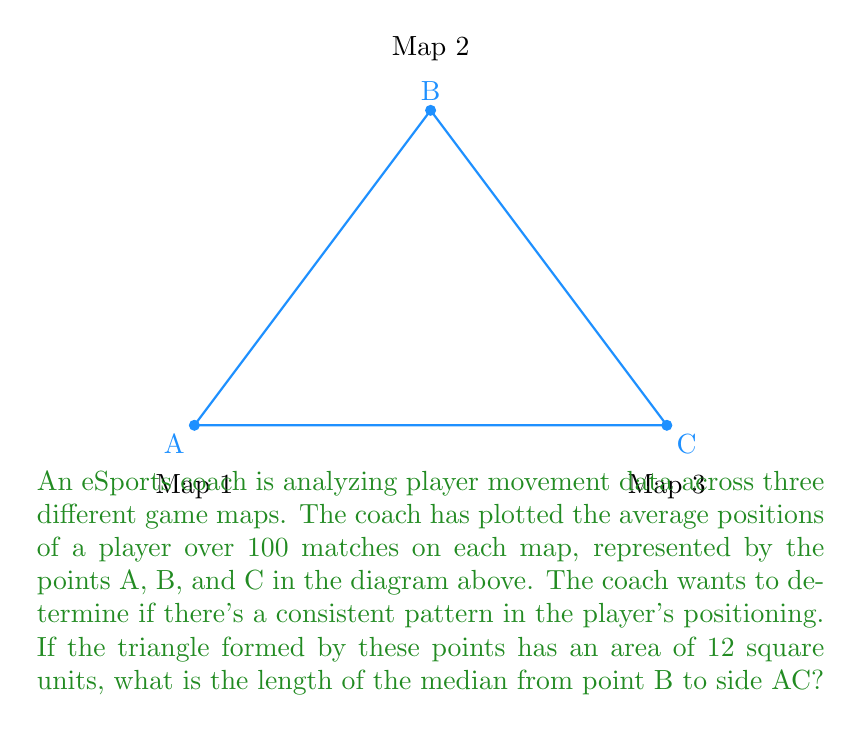Provide a solution to this math problem. Let's approach this step-by-step:

1) First, we need to recall the formula for the area of a triangle given the coordinates of its vertices. If we consider A as the origin (0,0), B as (3,4), and C as (6,0), we can use the formula:

   $$Area = \frac{1}{2}|x_1(y_2 - y_3) + x_2(y_3 - y_1) + x_3(y_1 - y_2)|$$

2) We're given that the area is 12 square units, so we don't need to calculate it. This information will be useful later.

3) To find the length of the median from B to AC, we can use the median formula:

   $$m_b^2 = \frac{1}{4}(2a^2 + 2c^2 - b^2)$$

   where $m_b$ is the median from B to AC, and a, b, c are the side lengths of the triangle.

4) We need to find the side lengths:
   AB = $\sqrt{3^2 + 4^2} = 5$
   BC = $\sqrt{3^2 + 4^2} = 5$
   AC = 6

5) Now we can plug these into the median formula:

   $$m_b^2 = \frac{1}{4}(2(6^2) + 2(5^2) - 5^2)$$

6) Simplify:
   $$m_b^2 = \frac{1}{4}(72 + 50 - 25) = \frac{97}{4}$$

7) Take the square root of both sides:
   $$m_b = \sqrt{\frac{97}{4}} = \frac{\sqrt{97}}{2}$$

This is our answer. We can leave it in this form as it's an exact representation of the length.
Answer: $\frac{\sqrt{97}}{2}$ 